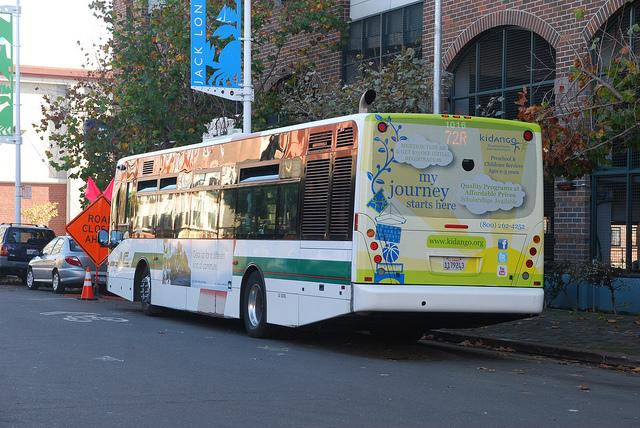What word is on the orange sign? Please explain your reasoning. road. That is the first word. 